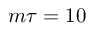Convert formula to latex. <formula><loc_0><loc_0><loc_500><loc_500>m \tau = 1 0</formula> 